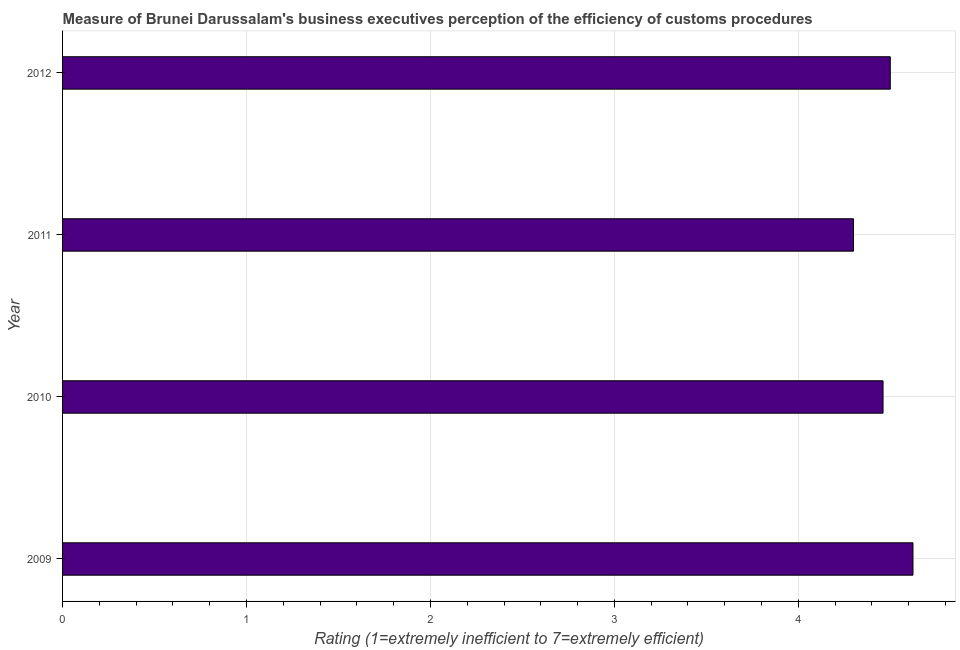Does the graph contain any zero values?
Give a very brief answer. No. Does the graph contain grids?
Provide a short and direct response. Yes. What is the title of the graph?
Offer a very short reply. Measure of Brunei Darussalam's business executives perception of the efficiency of customs procedures. What is the label or title of the X-axis?
Provide a succinct answer. Rating (1=extremely inefficient to 7=extremely efficient). Across all years, what is the maximum rating measuring burden of customs procedure?
Provide a short and direct response. 4.62. In which year was the rating measuring burden of customs procedure maximum?
Provide a short and direct response. 2009. What is the sum of the rating measuring burden of customs procedure?
Make the answer very short. 17.88. What is the difference between the rating measuring burden of customs procedure in 2009 and 2010?
Offer a very short reply. 0.16. What is the average rating measuring burden of customs procedure per year?
Ensure brevity in your answer.  4.47. What is the median rating measuring burden of customs procedure?
Offer a terse response. 4.48. In how many years, is the rating measuring burden of customs procedure greater than 1 ?
Give a very brief answer. 4. Do a majority of the years between 2011 and 2010 (inclusive) have rating measuring burden of customs procedure greater than 1 ?
Provide a succinct answer. No. What is the ratio of the rating measuring burden of customs procedure in 2010 to that in 2012?
Your response must be concise. 0.99. What is the difference between the highest and the second highest rating measuring burden of customs procedure?
Give a very brief answer. 0.12. What is the difference between the highest and the lowest rating measuring burden of customs procedure?
Give a very brief answer. 0.32. In how many years, is the rating measuring burden of customs procedure greater than the average rating measuring burden of customs procedure taken over all years?
Offer a terse response. 2. How many bars are there?
Your answer should be compact. 4. Are all the bars in the graph horizontal?
Your answer should be compact. Yes. Are the values on the major ticks of X-axis written in scientific E-notation?
Provide a succinct answer. No. What is the Rating (1=extremely inefficient to 7=extremely efficient) of 2009?
Your answer should be compact. 4.62. What is the Rating (1=extremely inefficient to 7=extremely efficient) in 2010?
Your answer should be compact. 4.46. What is the difference between the Rating (1=extremely inefficient to 7=extremely efficient) in 2009 and 2010?
Your response must be concise. 0.16. What is the difference between the Rating (1=extremely inefficient to 7=extremely efficient) in 2009 and 2011?
Ensure brevity in your answer.  0.32. What is the difference between the Rating (1=extremely inefficient to 7=extremely efficient) in 2009 and 2012?
Your answer should be very brief. 0.12. What is the difference between the Rating (1=extremely inefficient to 7=extremely efficient) in 2010 and 2011?
Offer a very short reply. 0.16. What is the difference between the Rating (1=extremely inefficient to 7=extremely efficient) in 2010 and 2012?
Provide a succinct answer. -0.04. What is the difference between the Rating (1=extremely inefficient to 7=extremely efficient) in 2011 and 2012?
Provide a short and direct response. -0.2. What is the ratio of the Rating (1=extremely inefficient to 7=extremely efficient) in 2009 to that in 2010?
Make the answer very short. 1.04. What is the ratio of the Rating (1=extremely inefficient to 7=extremely efficient) in 2009 to that in 2011?
Provide a succinct answer. 1.07. What is the ratio of the Rating (1=extremely inefficient to 7=extremely efficient) in 2010 to that in 2012?
Make the answer very short. 0.99. What is the ratio of the Rating (1=extremely inefficient to 7=extremely efficient) in 2011 to that in 2012?
Your answer should be very brief. 0.96. 